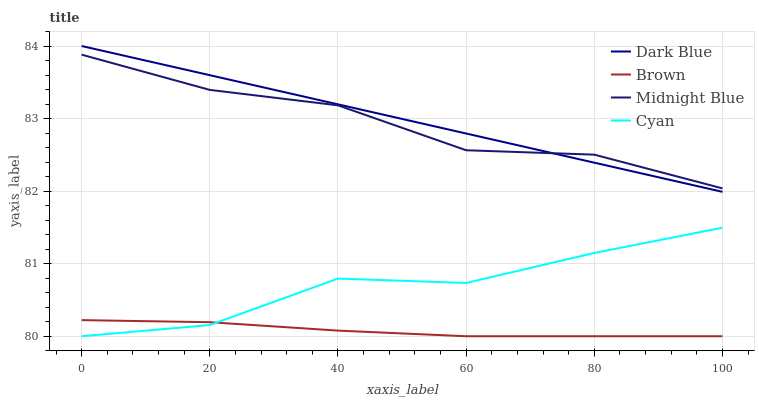Does Brown have the minimum area under the curve?
Answer yes or no. Yes. Does Dark Blue have the maximum area under the curve?
Answer yes or no. Yes. Does Cyan have the minimum area under the curve?
Answer yes or no. No. Does Cyan have the maximum area under the curve?
Answer yes or no. No. Is Dark Blue the smoothest?
Answer yes or no. Yes. Is Cyan the roughest?
Answer yes or no. Yes. Is Midnight Blue the smoothest?
Answer yes or no. No. Is Midnight Blue the roughest?
Answer yes or no. No. Does Midnight Blue have the lowest value?
Answer yes or no. No. Does Dark Blue have the highest value?
Answer yes or no. Yes. Does Cyan have the highest value?
Answer yes or no. No. Is Brown less than Midnight Blue?
Answer yes or no. Yes. Is Dark Blue greater than Brown?
Answer yes or no. Yes. Does Brown intersect Cyan?
Answer yes or no. Yes. Is Brown less than Cyan?
Answer yes or no. No. Is Brown greater than Cyan?
Answer yes or no. No. Does Brown intersect Midnight Blue?
Answer yes or no. No. 